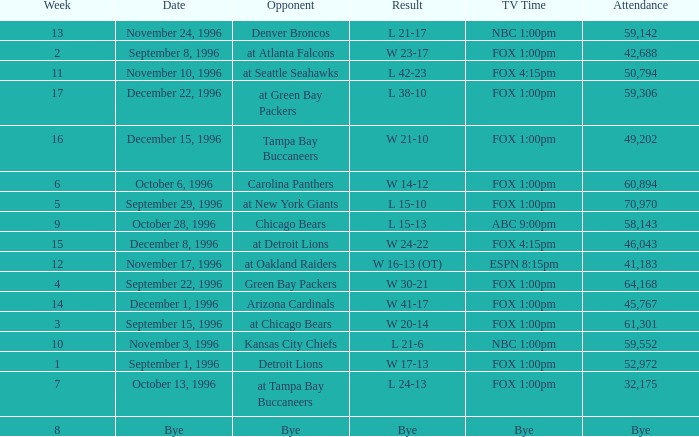Tell me the opponent for november 24, 1996 Denver Broncos. 